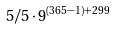Convert formula to latex. <formula><loc_0><loc_0><loc_500><loc_500>5 / 5 \cdot 9 ^ { ( 3 6 5 - 1 ) + 2 9 9 }</formula> 